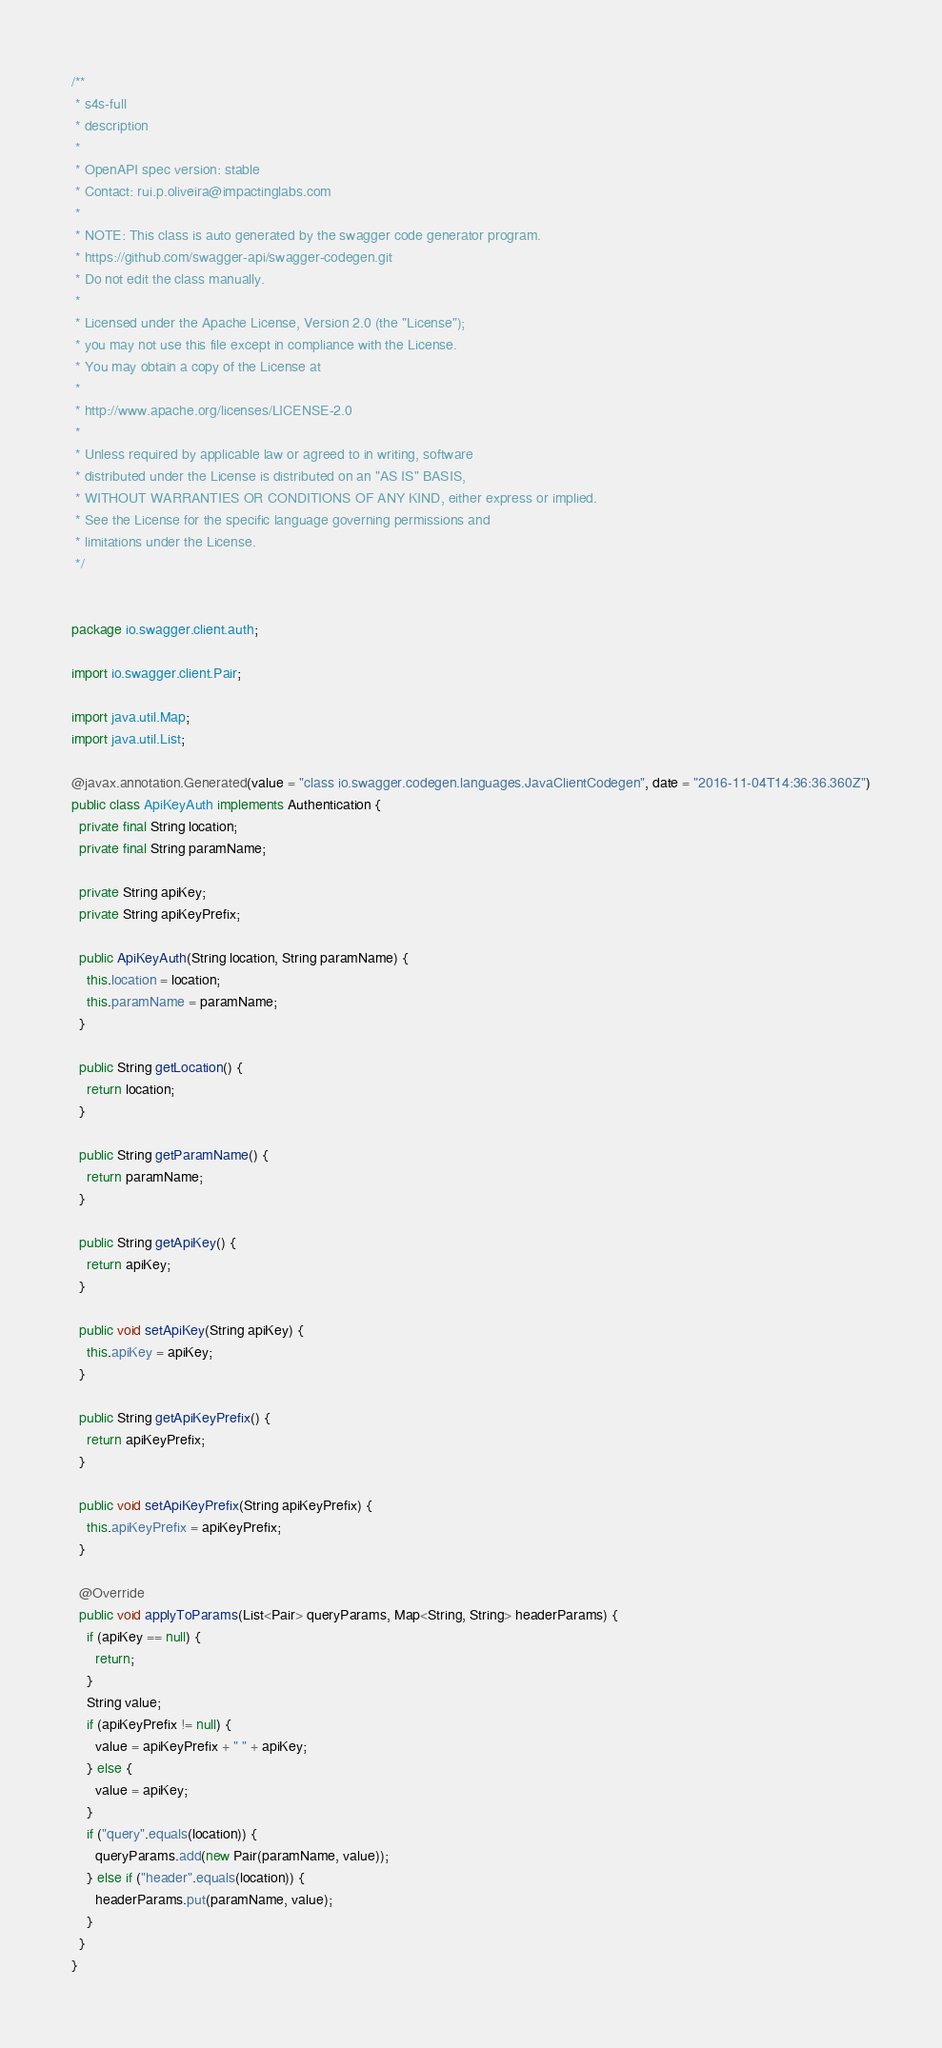<code> <loc_0><loc_0><loc_500><loc_500><_Java_>/**
 * s4s-full
 * description
 *
 * OpenAPI spec version: stable
 * Contact: rui.p.oliveira@impactinglabs.com
 *
 * NOTE: This class is auto generated by the swagger code generator program.
 * https://github.com/swagger-api/swagger-codegen.git
 * Do not edit the class manually.
 *
 * Licensed under the Apache License, Version 2.0 (the "License");
 * you may not use this file except in compliance with the License.
 * You may obtain a copy of the License at
 *
 * http://www.apache.org/licenses/LICENSE-2.0
 *
 * Unless required by applicable law or agreed to in writing, software
 * distributed under the License is distributed on an "AS IS" BASIS,
 * WITHOUT WARRANTIES OR CONDITIONS OF ANY KIND, either express or implied.
 * See the License for the specific language governing permissions and
 * limitations under the License.
 */


package io.swagger.client.auth;

import io.swagger.client.Pair;

import java.util.Map;
import java.util.List;

@javax.annotation.Generated(value = "class io.swagger.codegen.languages.JavaClientCodegen", date = "2016-11-04T14:36:36.360Z")
public class ApiKeyAuth implements Authentication {
  private final String location;
  private final String paramName;

  private String apiKey;
  private String apiKeyPrefix;

  public ApiKeyAuth(String location, String paramName) {
    this.location = location;
    this.paramName = paramName;
  }

  public String getLocation() {
    return location;
  }

  public String getParamName() {
    return paramName;
  }

  public String getApiKey() {
    return apiKey;
  }

  public void setApiKey(String apiKey) {
    this.apiKey = apiKey;
  }

  public String getApiKeyPrefix() {
    return apiKeyPrefix;
  }

  public void setApiKeyPrefix(String apiKeyPrefix) {
    this.apiKeyPrefix = apiKeyPrefix;
  }

  @Override
  public void applyToParams(List<Pair> queryParams, Map<String, String> headerParams) {
    if (apiKey == null) {
      return;
    }
    String value;
    if (apiKeyPrefix != null) {
      value = apiKeyPrefix + " " + apiKey;
    } else {
      value = apiKey;
    }
    if ("query".equals(location)) {
      queryParams.add(new Pair(paramName, value));
    } else if ("header".equals(location)) {
      headerParams.put(paramName, value);
    }
  }
}
</code> 